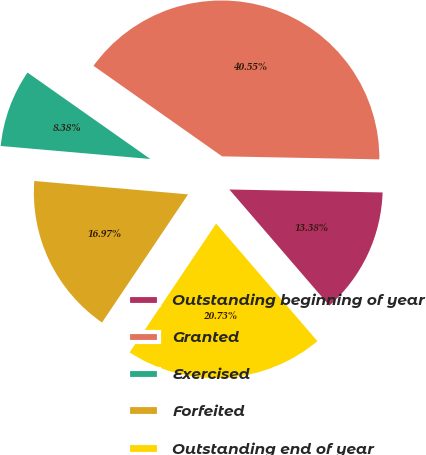Convert chart. <chart><loc_0><loc_0><loc_500><loc_500><pie_chart><fcel>Outstanding beginning of year<fcel>Granted<fcel>Exercised<fcel>Forfeited<fcel>Outstanding end of year<nl><fcel>13.38%<fcel>40.55%<fcel>8.38%<fcel>16.97%<fcel>20.73%<nl></chart> 